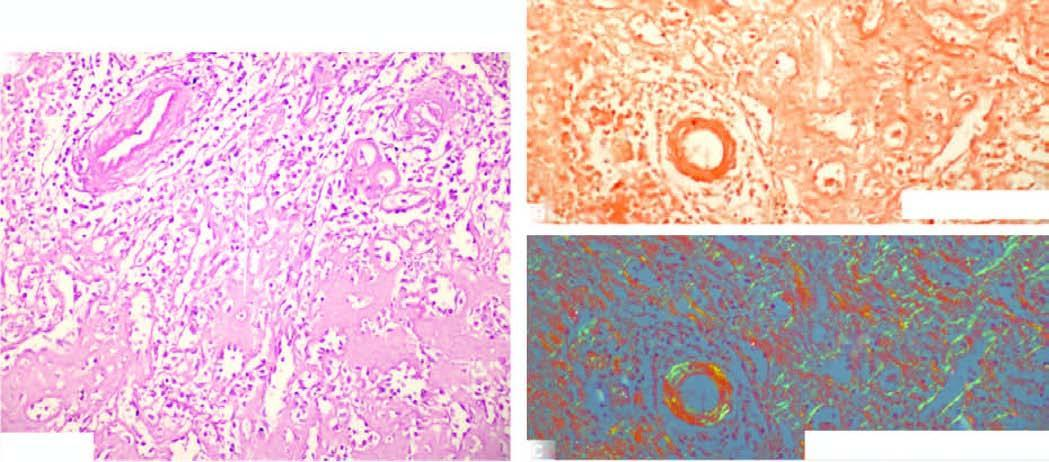what shows apple-green birefringence?
Answer the question using a single word or phrase. C 